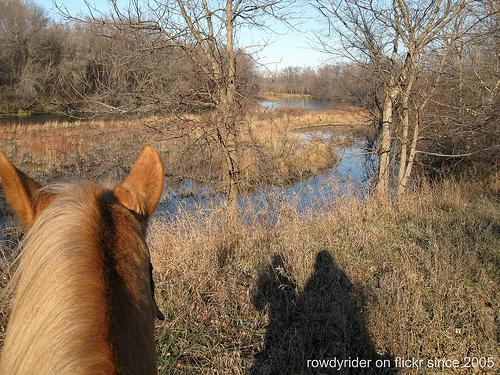Identify a prominent non-natural element in the image and state its content. The photo's watermark says "rowdyrider on Flickr since 2005." State a distinguishing feature of the horse's appearance and something about its surroundings. The horse has blonde hair and a long crest, while standing near a shadow cast next to it on the field. Provide a description of the water body found in the image. The river winds and twists, reflecting the blue sky, and is located between trees on the near side bank. What unique feature of the horse's face and ears can be observed in the image? The horse has pointed ears and a right ear that is slightly tucked, giving it a distinct look. Briefly describe the environment where the horse is located. The horse stands in a field with dry weeds, near a river passing through, and surrounded by trees without leaves. Explain what can be observed about the sky in the image. The sky is light blue with a treeline making the horizon in the image. Mention the primary object in the image and highlight its color and a unique feature. The horse is light brown with pointed ears and a mane that is brushed to one side. Describe the shadow present in the image and its location. There is a shadow of the rider and the horse against the ground, partially on a portion of grass. Describe the horse's posture and the position of its mane. The horse stands to the left of the picture, with its mane shifted to the left and displaying pointy ears. What can be observed about the state of vegetation in this image? The grass is dry and tall, with trees that are bare and have no leaves, and some bushes in the background. 